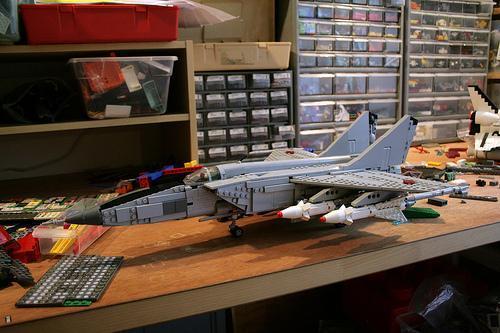How many full fighter jets can be seen?
Give a very brief answer. 1. How many missiles can be seen?
Give a very brief answer. 2. How many tail fins on the gray jet?
Give a very brief answer. 2. 